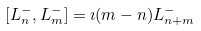<formula> <loc_0><loc_0><loc_500><loc_500>[ L ^ { - } _ { n } , L ^ { - } _ { m } ] = \imath ( m - n ) L ^ { - } _ { n + m }</formula> 